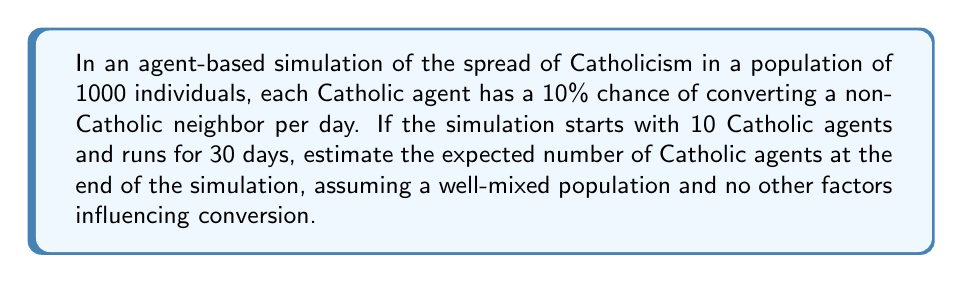What is the answer to this math problem? To solve this problem, we'll use a simplified logistic growth model, which is often used in agent-based simulations for population dynamics. The steps are as follows:

1) Let $P(t)$ be the number of Catholic agents at time $t$.

2) The rate of change of Catholic agents can be modeled by the differential equation:

   $$\frac{dP}{dt} = rP(1-\frac{P}{N})$$

   Where:
   - $r$ is the growth rate
   - $N$ is the total population (1000 in this case)

3) In our case, $r = 0.1$ (10% chance of conversion per day per Catholic agent)

4) The solution to this differential equation is the logistic function:

   $$P(t) = \frac{N}{1 + (\frac{N}{P_0} - 1)e^{-rt}}$$

   Where $P_0$ is the initial number of Catholic agents (10 in this case)

5) Plugging in our values:

   $$P(t) = \frac{1000}{1 + (\frac{1000}{10} - 1)e^{-0.1t}}$$

6) To find $P(30)$, we substitute $t = 30$:

   $$P(30) = \frac{1000}{1 + 99e^{-3}} \approx 952$$

7) Therefore, after 30 days, we expect approximately 952 Catholic agents.

Note: This is a simplified model and real-world agent-based simulations would include more complex factors such as spatial distribution, individual variation in conversion probabilities, and potential for deconversion.
Answer: 952 Catholic agents 